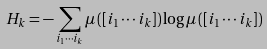<formula> <loc_0><loc_0><loc_500><loc_500>H _ { k } = - \sum _ { i _ { 1 } \cdots i _ { k } } \mu \left ( [ i _ { 1 } \cdots i _ { k } ] \right ) \log \mu \left ( [ i _ { 1 } \cdots i _ { k } ] \right )</formula> 